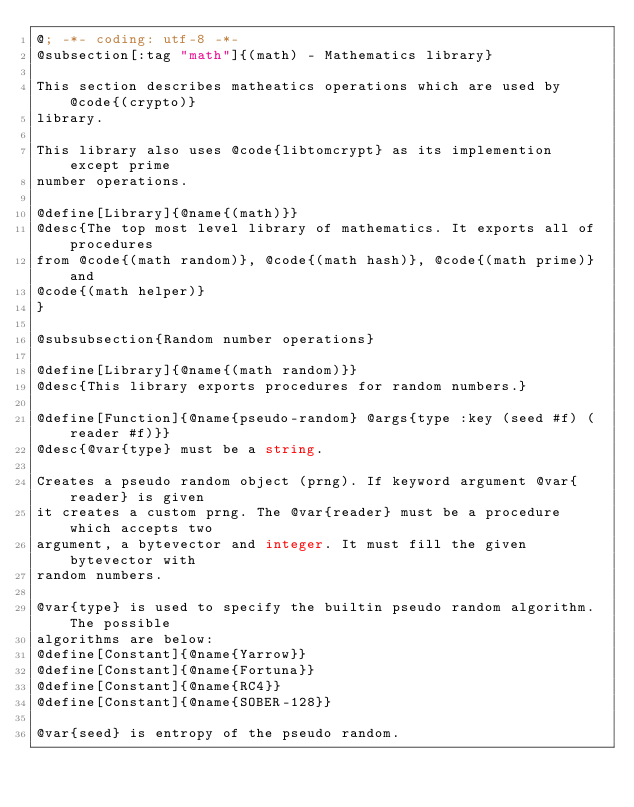<code> <loc_0><loc_0><loc_500><loc_500><_Racket_>@; -*- coding: utf-8 -*-
@subsection[:tag "math"]{(math) - Mathematics library}

This section describes matheatics operations which are used by @code{(crypto)}
library.

This library also uses @code{libtomcrypt} as its implemention except prime
number operations.

@define[Library]{@name{(math)}}
@desc{The top most level library of mathematics. It exports all of procedures
from @code{(math random)}, @code{(math hash)}, @code{(math prime)} and
@code{(math helper)}
}

@subsubsection{Random number operations}

@define[Library]{@name{(math random)}}
@desc{This library exports procedures for random numbers.}

@define[Function]{@name{pseudo-random} @args{type :key (seed #f) (reader #f)}}
@desc{@var{type} must be a string.

Creates a pseudo random object (prng). If keyword argument @var{reader} is given
it creates a custom prng. The @var{reader} must be a procedure which accepts two
argument, a bytevector and integer. It must fill the given bytevector with
random numbers.

@var{type} is used to specify the builtin pseudo random algorithm. The possible
algorithms are below:
@define[Constant]{@name{Yarrow}}
@define[Constant]{@name{Fortuna}}
@define[Constant]{@name{RC4}}
@define[Constant]{@name{SOBER-128}}

@var{seed} is entropy of the pseudo random.
</code> 